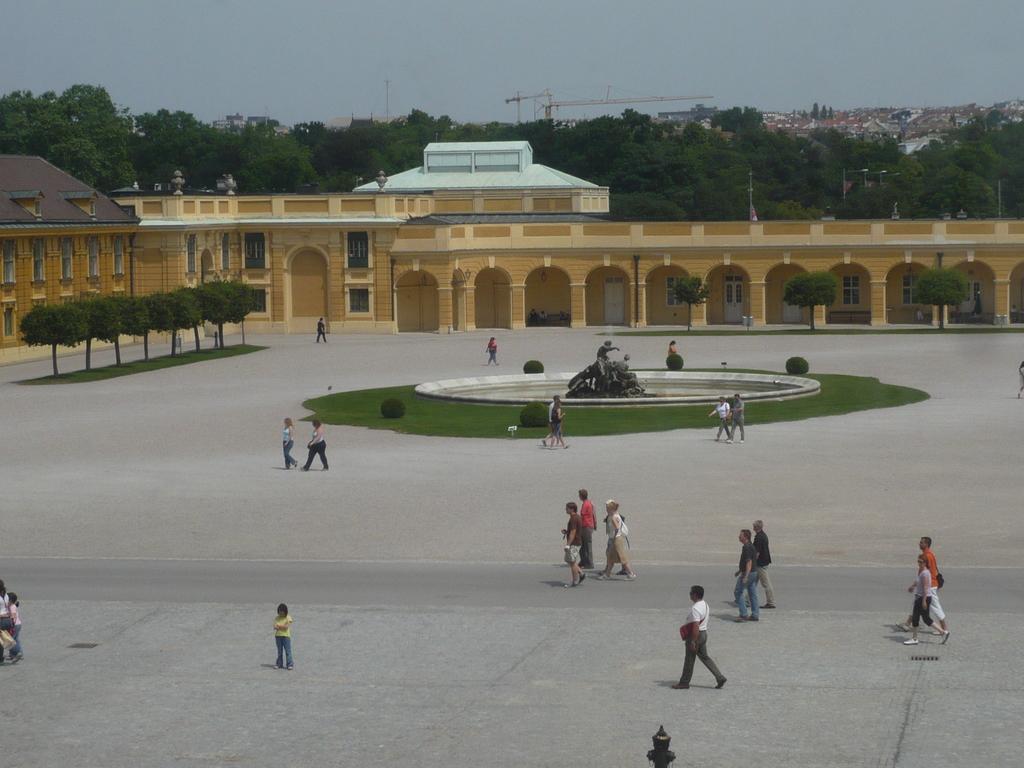Please provide a concise description of this image. Here few people both men and women are walking on the road. On the left at the bottom there is a woman standing on the road. In the background there are buildings,plants,grass,sculpture,water,cranes,trees and sky. 